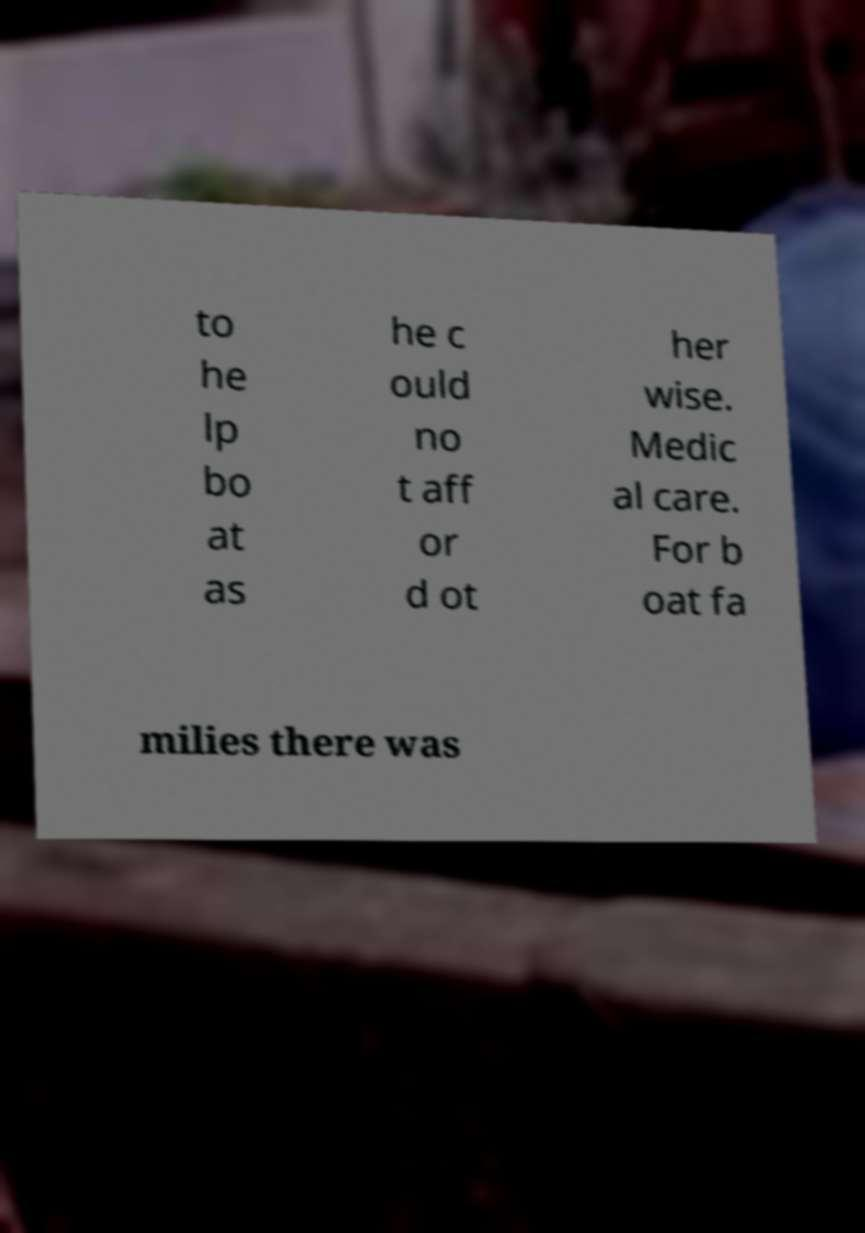Can you accurately transcribe the text from the provided image for me? to he lp bo at as he c ould no t aff or d ot her wise. Medic al care. For b oat fa milies there was 